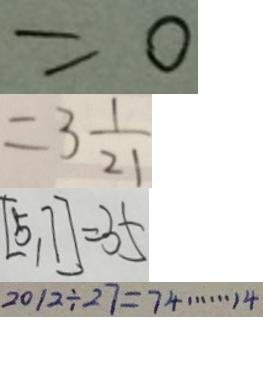<formula> <loc_0><loc_0><loc_500><loc_500>= 0 
 = 3 \frac { 1 } { 2 1 } 
 [ 5 , 7 ] = 3 5 
 2 0 1 2 \div 2 7 = 7 4 \cdots 1 4</formula> 